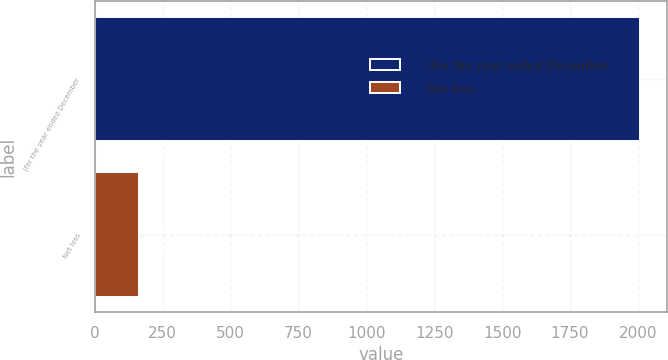Convert chart. <chart><loc_0><loc_0><loc_500><loc_500><bar_chart><fcel>(for the year ended December<fcel>Net loss<nl><fcel>2006<fcel>163<nl></chart> 